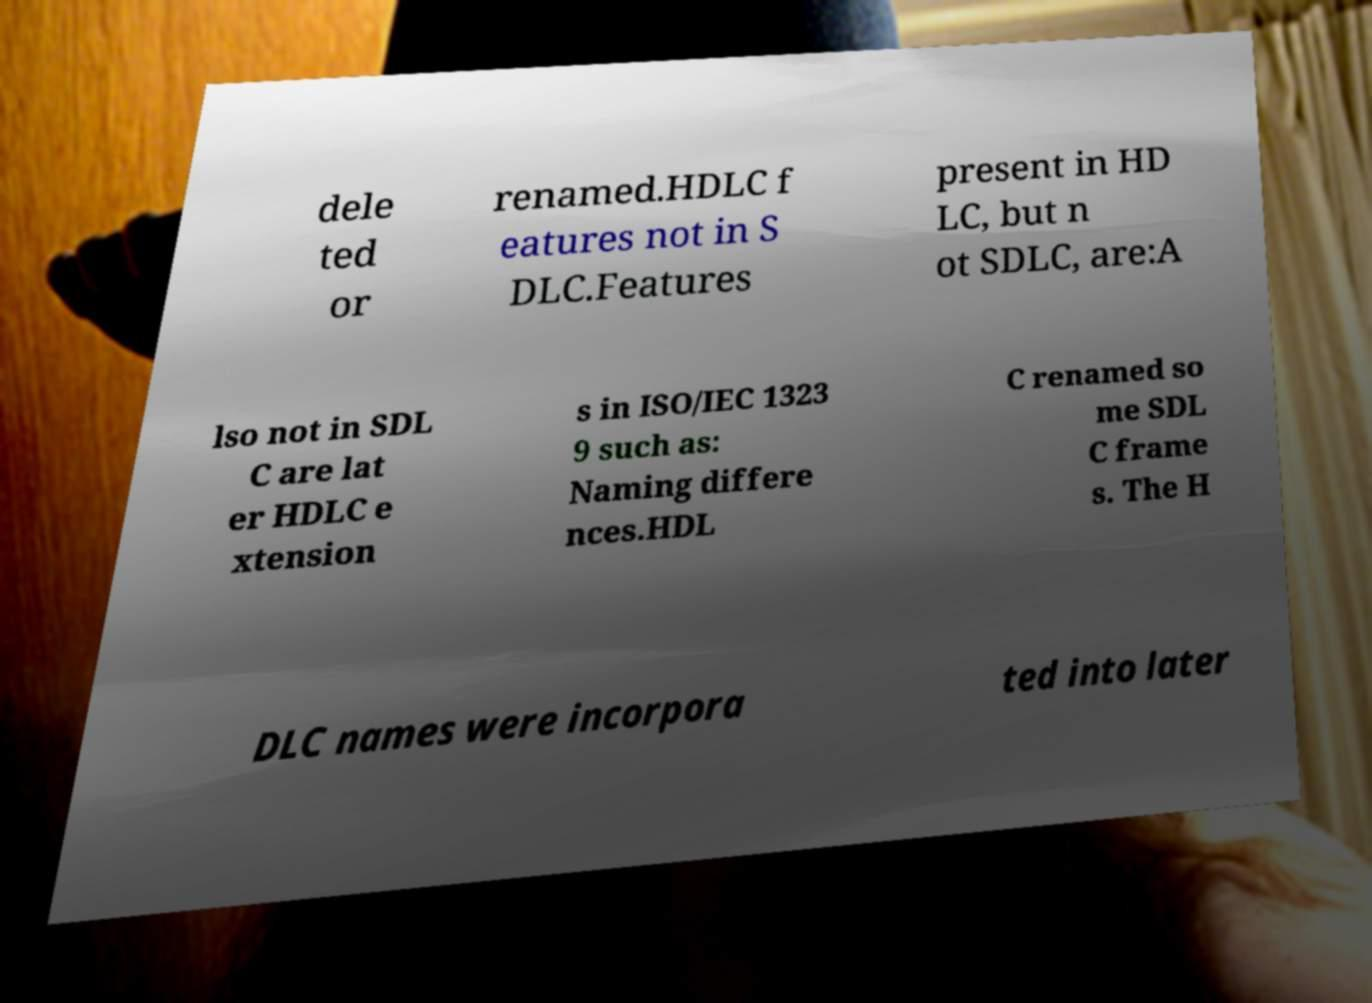I need the written content from this picture converted into text. Can you do that? dele ted or renamed.HDLC f eatures not in S DLC.Features present in HD LC, but n ot SDLC, are:A lso not in SDL C are lat er HDLC e xtension s in ISO/IEC 1323 9 such as: Naming differe nces.HDL C renamed so me SDL C frame s. The H DLC names were incorpora ted into later 